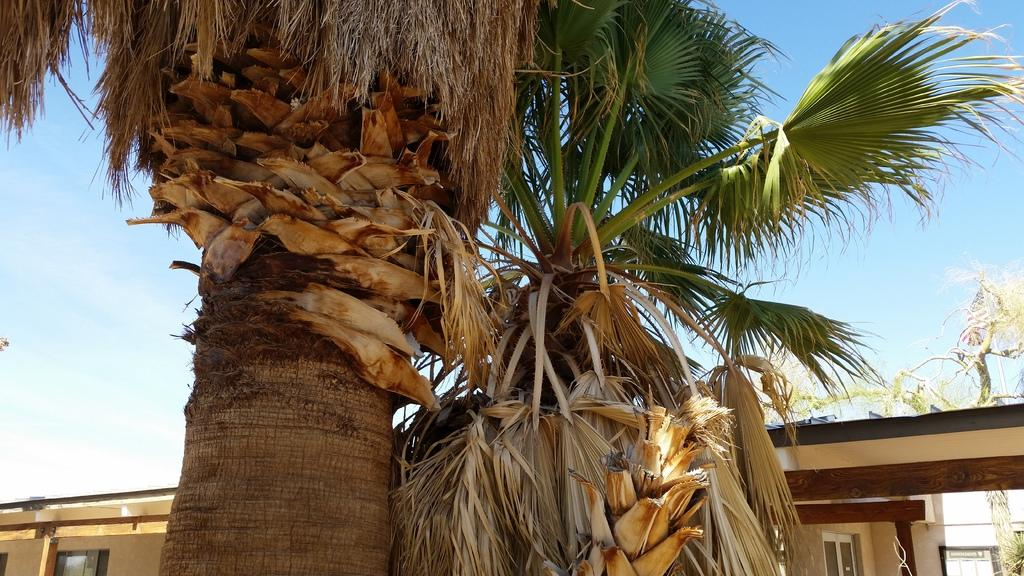What type of vegetation can be seen in the image? There are trees in the image. What structures are visible in the background of the image? There are houses in the background of the image. What is visible in the sky in the image? The sky is clear and visible in the image. What type of property is being sold in the image? There is no indication of a property being sold in the image. What time of day is depicted in the image? The time of day cannot be determined from the image, as there are no specific clues or indicators. 